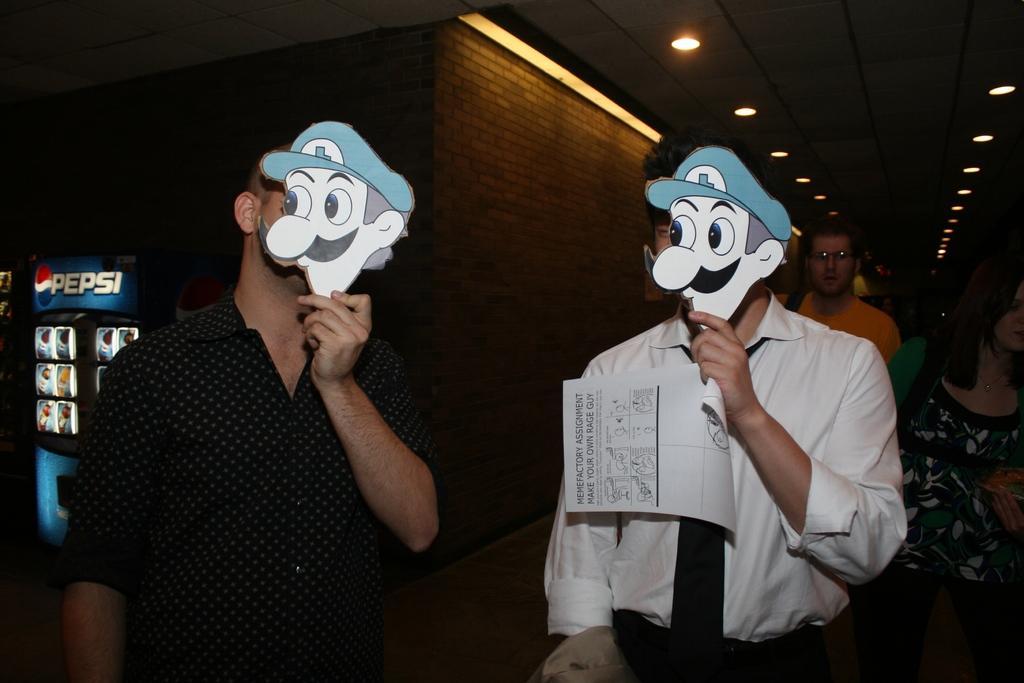How would you summarize this image in a sentence or two? Here we can see two women holding masks with their hands. Here we can see a paper, fridge, wall, lights, and few persons. 